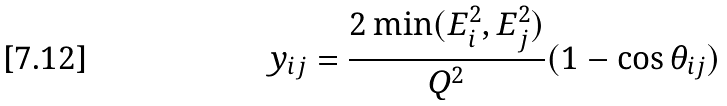<formula> <loc_0><loc_0><loc_500><loc_500>y _ { i j } = \frac { 2 \min ( E _ { i } ^ { 2 } , E _ { j } ^ { 2 } ) } { Q ^ { 2 } } ( 1 - \cos \theta _ { i j } )</formula> 